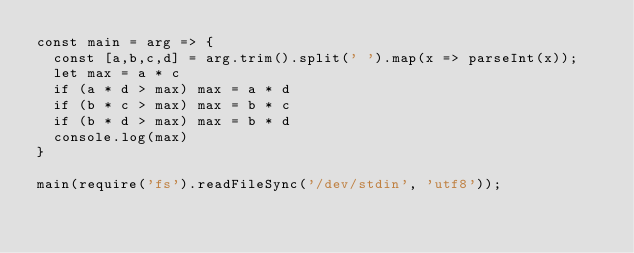<code> <loc_0><loc_0><loc_500><loc_500><_JavaScript_>const main = arg => {
  const [a,b,c,d] = arg.trim().split(' ').map(x => parseInt(x));
  let max = a * c
  if (a * d > max) max = a * d
  if (b * c > max) max = b * c
  if (b * d > max) max = b * d
  console.log(max)
}

main(require('fs').readFileSync('/dev/stdin', 'utf8'));</code> 